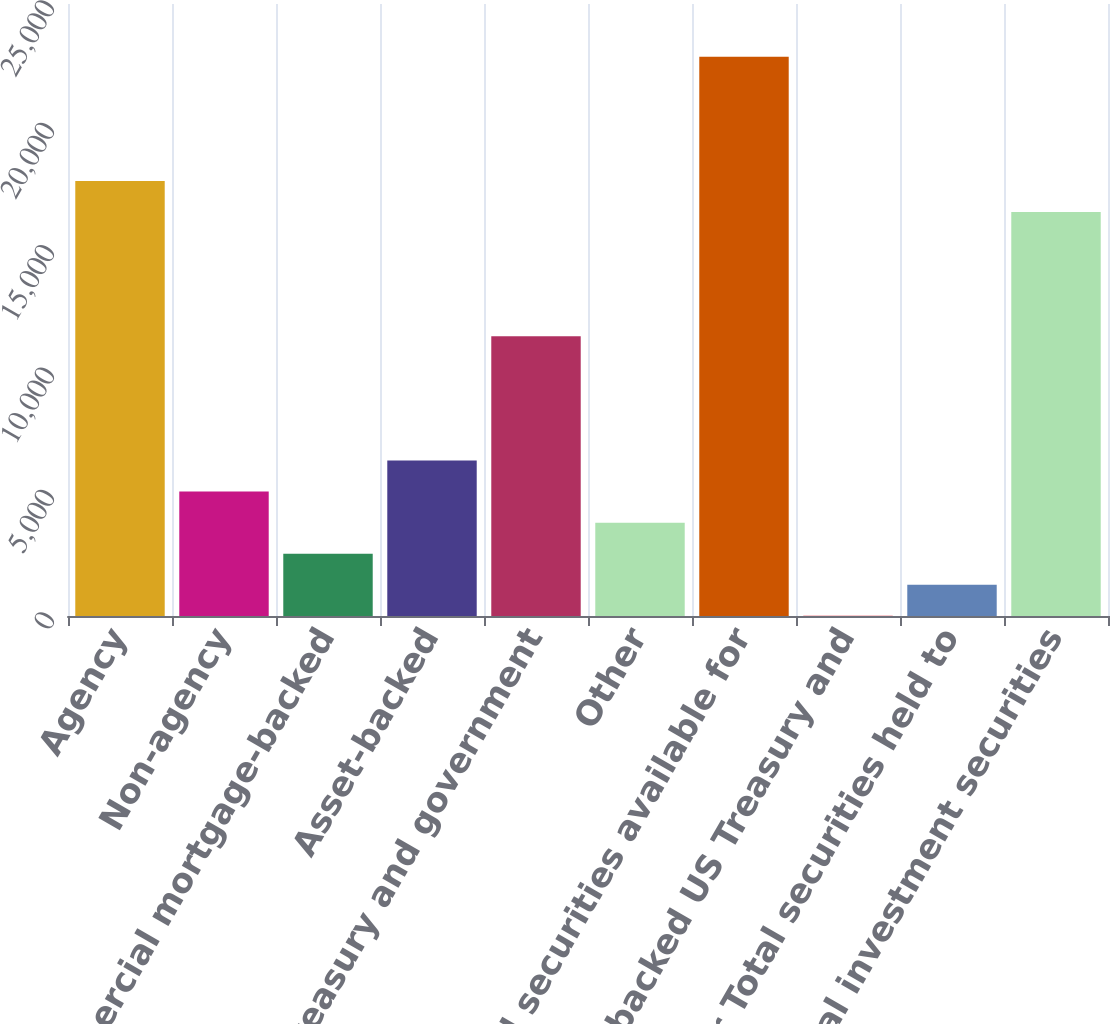<chart> <loc_0><loc_0><loc_500><loc_500><bar_chart><fcel>Agency<fcel>Non-agency<fcel>Commercial mortgage-backed<fcel>Asset-backed<fcel>US Treasury and government<fcel>Other<fcel>Total securities available for<fcel>Asset-backed US Treasury and<fcel>Other Total securities held to<fcel>Total investment securities<nl><fcel>17773<fcel>5083<fcel>2545<fcel>6352<fcel>11428<fcel>3814<fcel>22849<fcel>7<fcel>1276<fcel>16504<nl></chart> 